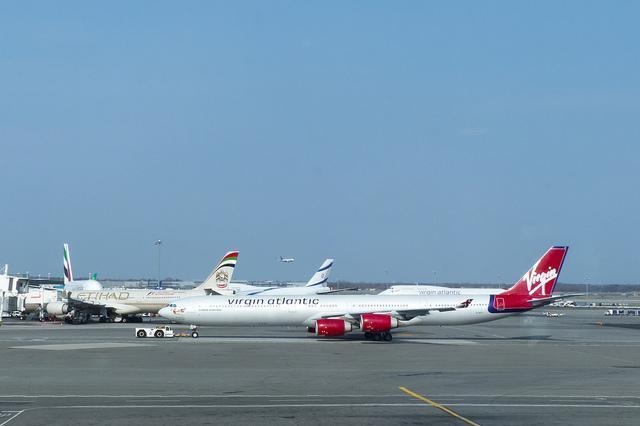How many engines does the nearest plane have?
Give a very brief answer. 2. How many airplanes are there?
Give a very brief answer. 2. 